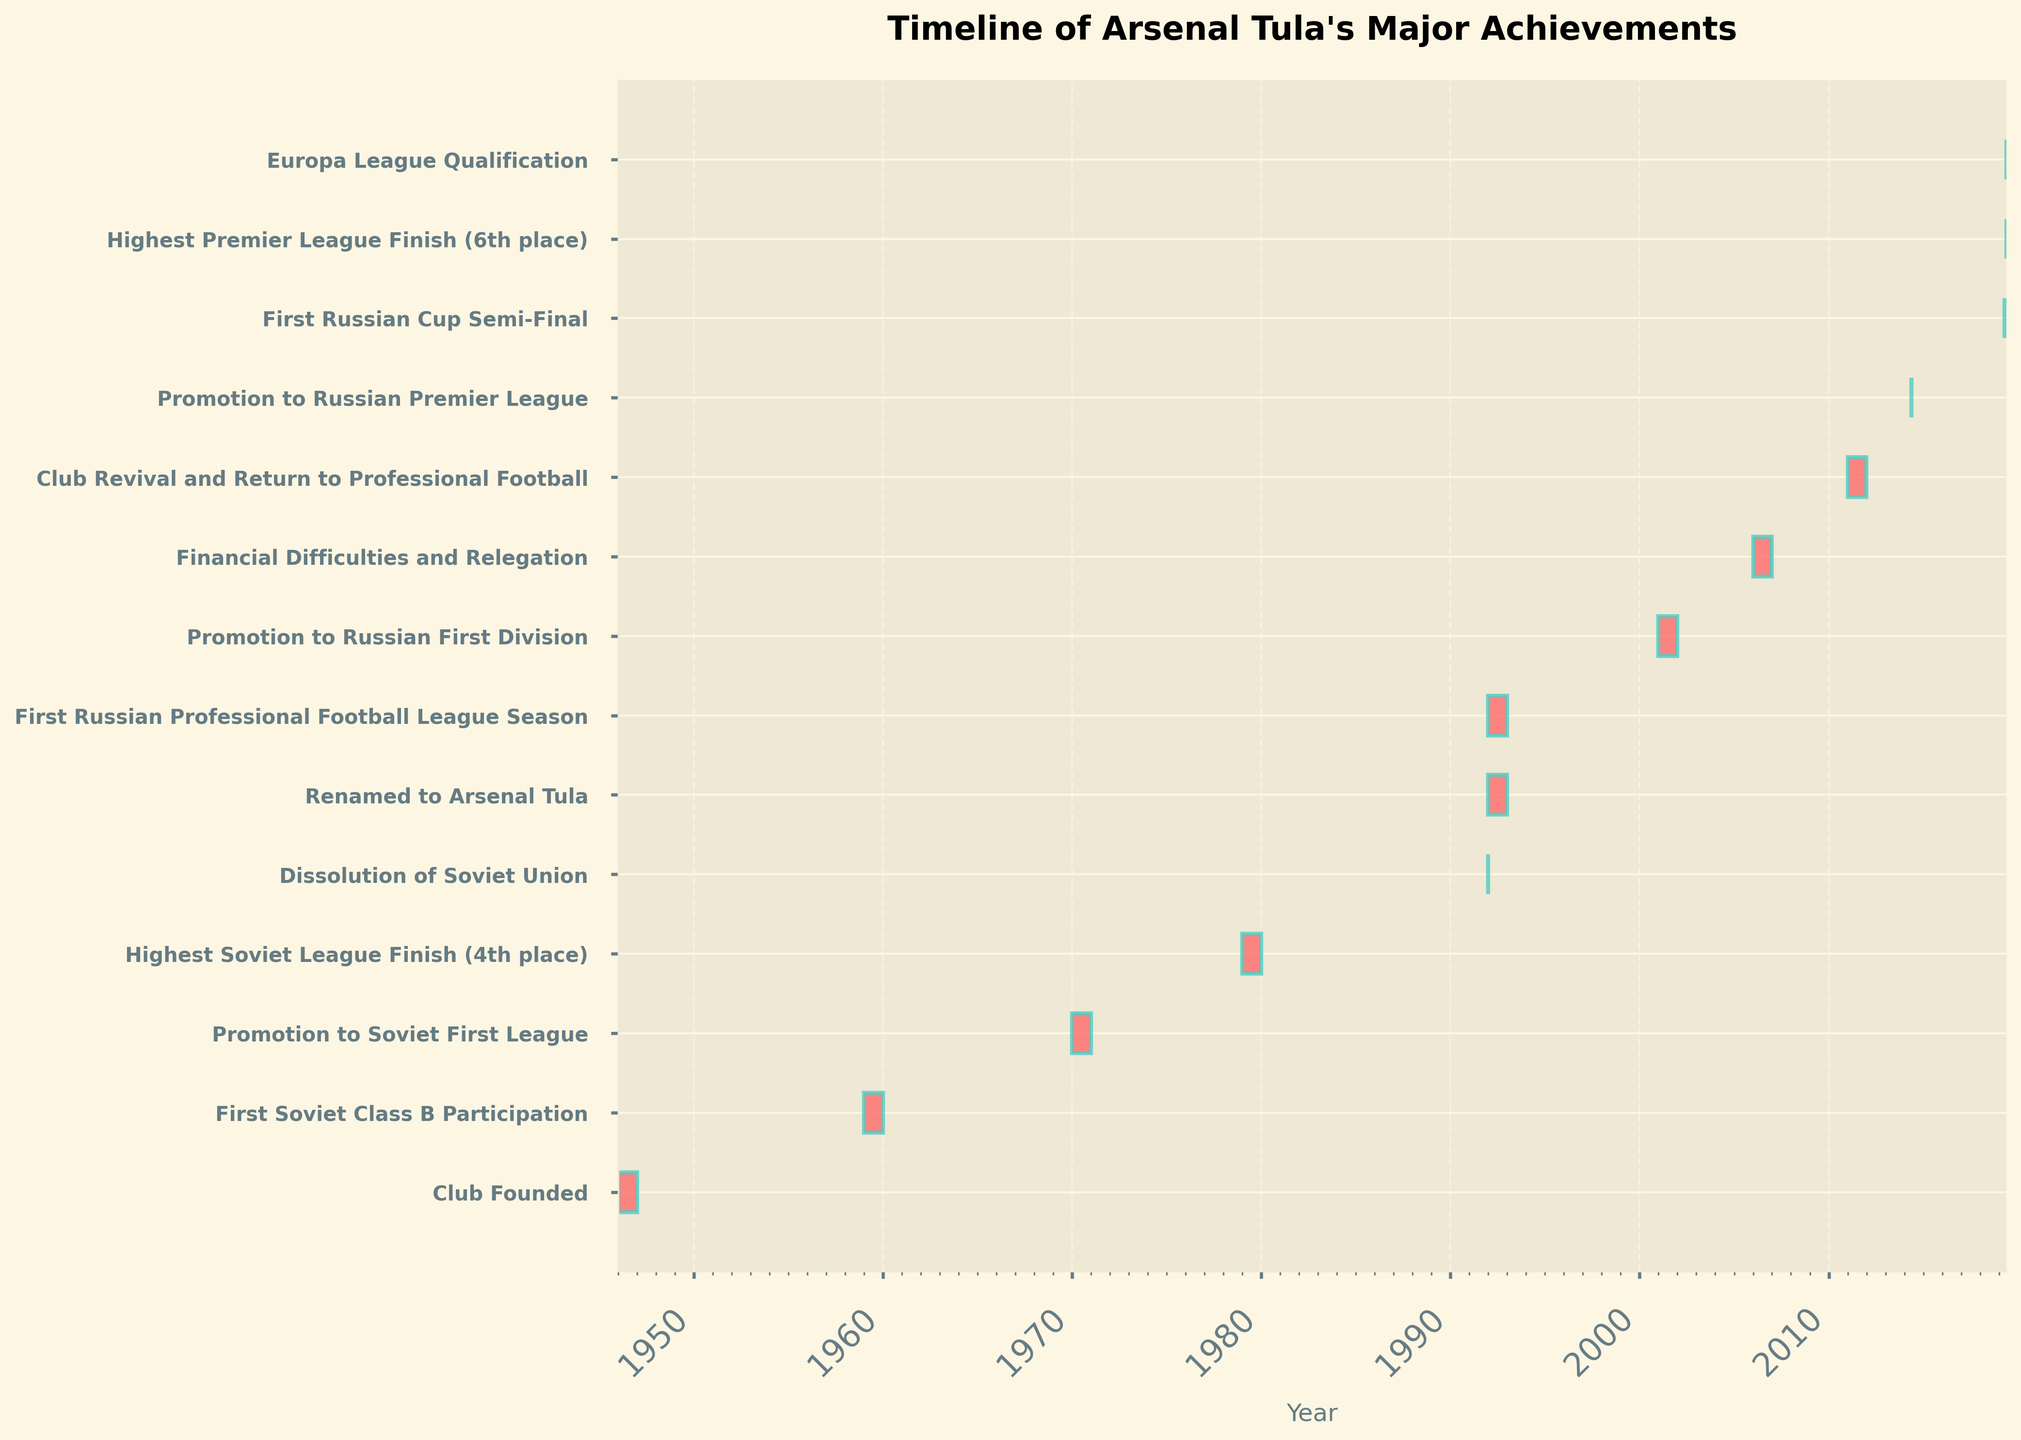How long did it take for Arsenal Tula to go from being founded to playing in the Soviet Class B? The club was founded in 1946, and their first participation in Soviet Class B was in 1959. 1959 minus 1946 gives 13 years.
Answer: 13 years How many years did Arsenal Tula spend in the Soviet leagues between their first Soviet Class B participation and their highest Soviet league finish? The first participation in Soviet Class B was in 1959. Their highest finish (4th place) was achieved in 1979. 1979 minus 1959 gives 20 years.
Answer: 20 years What event occurred immediately after the dissolution of the Soviet Union? The dissolution of the Soviet Union was on December 26, 1991. The next event was the club being renamed to Arsenal Tula in 1992.
Answer: Renamed to Arsenal Tula Which accomplishment took place on the same date as the Europa League qualification? Both the highest Premier League finish (6th place) and the Europa League qualification occurred on May 26, 2019.
Answer: Highest Premier League Finish (6th place) Which milestone took the club the longest time to achieve from the previous milestone? The longest gap is between the highest Soviet League finish in 1979 and the dissolution of the Soviet Union in 1991, taking 12 years.
Answer: 12 years When did Arsenal Tula first get promoted to the Russian Premier League? The promotion to the Russian Premier League happened on May 15, 2014, as shown on the Gantt chart.
Answer: May 15, 2014 Which event marked the return of Arsenal Tula to professional football after a period of financial difficulties? The club revival and return to professional football occurred in 2011 following the financial difficulties and relegation in 2006.
Answer: Club Revival and Return to Professional Football How many significant events, including the founding, happened before the dissolution of the Soviet Union? The events before the dissolution of the Soviet Union on December 26, 1991, were the club founding, first Soviet Class B participation, promotion to Soviet First League, and highest Soviet league finish (4 events).
Answer: 4 events Which event had the shortest duration on the timeline? The events occurring on a single day, including the promotion to the Russian Premier League, first Russian Cup semi-final, highest Premier League finish, and Europa League qualification, are the shortest in duration.
Answer: Promotion to Russian Premier League; First Russian Cup Semi-Final; Highest Premier League Finish (6th place); Europa League Qualification 